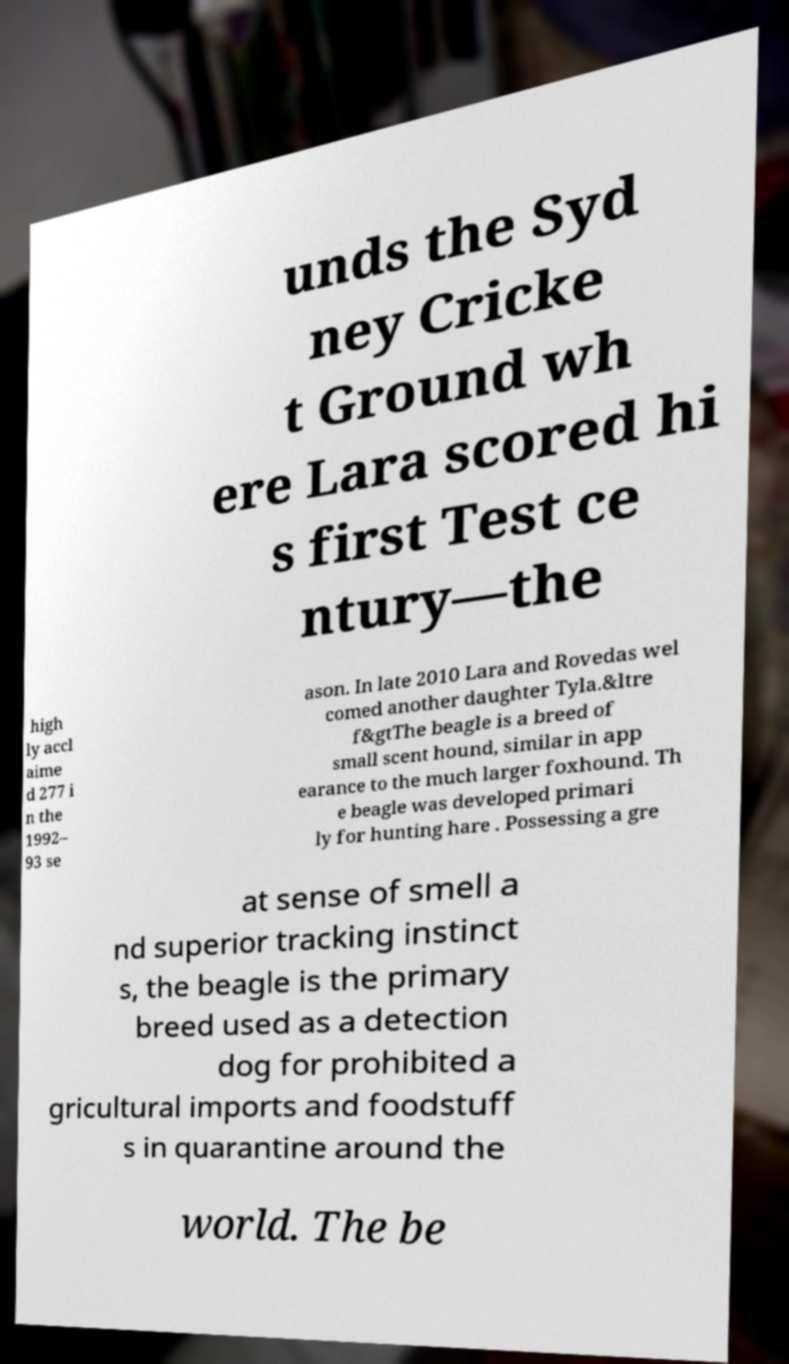Could you extract and type out the text from this image? unds the Syd ney Cricke t Ground wh ere Lara scored hi s first Test ce ntury—the high ly accl aime d 277 i n the 1992– 93 se ason. In late 2010 Lara and Rovedas wel comed another daughter Tyla.&ltre f&gtThe beagle is a breed of small scent hound, similar in app earance to the much larger foxhound. Th e beagle was developed primari ly for hunting hare . Possessing a gre at sense of smell a nd superior tracking instinct s, the beagle is the primary breed used as a detection dog for prohibited a gricultural imports and foodstuff s in quarantine around the world. The be 